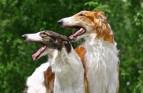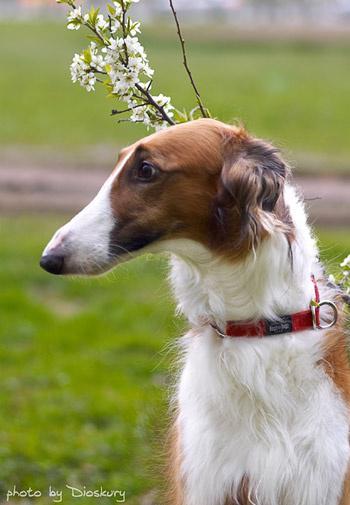The first image is the image on the left, the second image is the image on the right. Evaluate the accuracy of this statement regarding the images: "The left image contains exactly two dogs.". Is it true? Answer yes or no. Yes. The first image is the image on the left, the second image is the image on the right. Analyze the images presented: Is the assertion "All hound dogs have their heads turned to the left, and at least two dogs have open mouths." valid? Answer yes or no. Yes. 